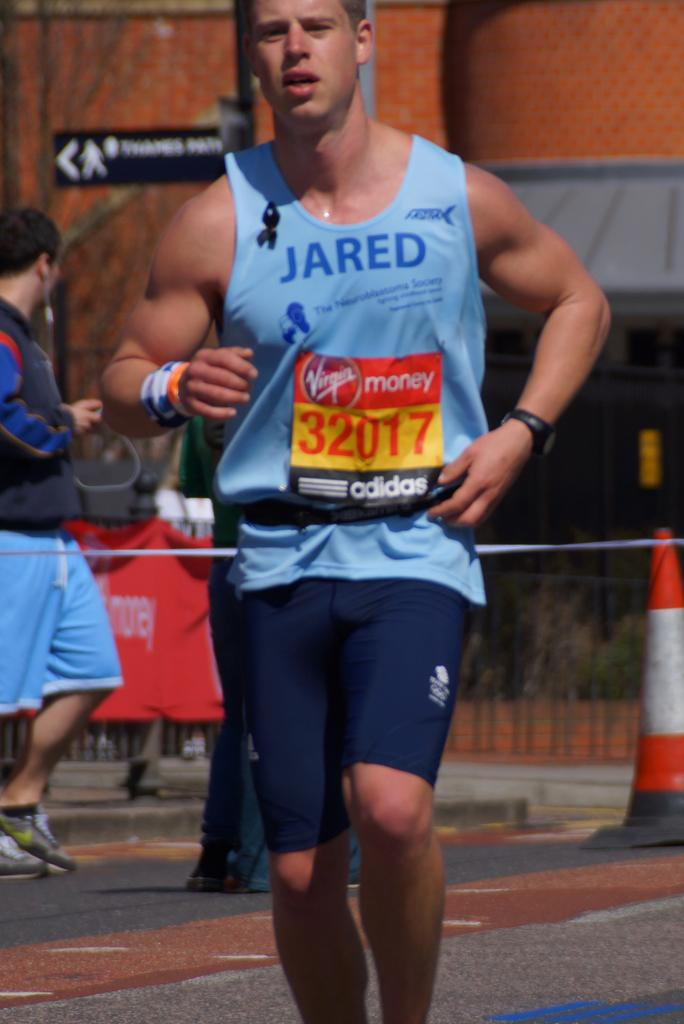<image>
Create a compact narrative representing the image presented. A male runner in a stringer that says Jared. 